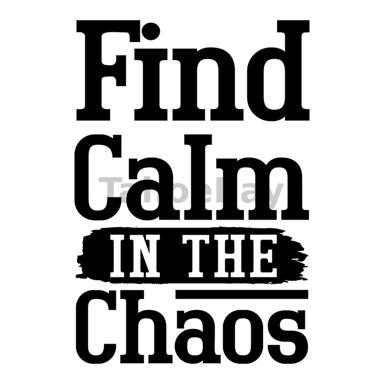What is the text on the image suggesting? The phrase 'Find Calm IN THE Chaos' on the image suggests a philosophy of seeking inner peace and stability despite the presence of disorder and stress in our external environment. It implies that amidst the busyness and often overwhelming nature of our daily lives, there is a challenge as well as solace available in staying centered and serene. This idea encourages an approach to personal calmness as an active choice, one that involves mindfulness and the conscious effort to detach from tumultuous situations, viewing them as opportunities for personal growth and tranquility. 